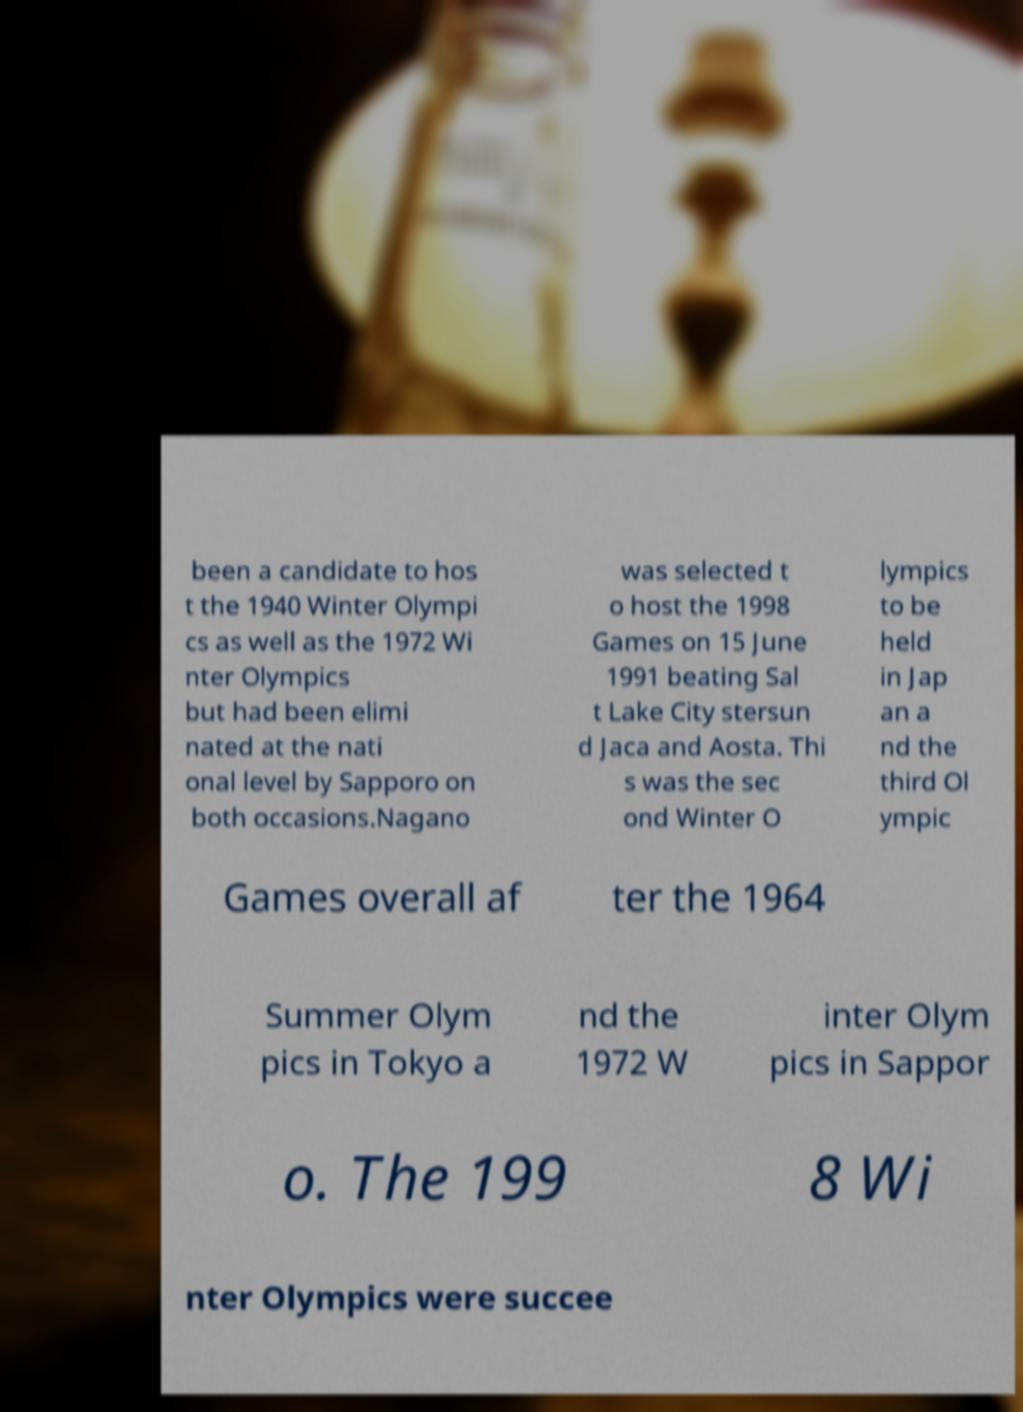Please read and relay the text visible in this image. What does it say? been a candidate to hos t the 1940 Winter Olympi cs as well as the 1972 Wi nter Olympics but had been elimi nated at the nati onal level by Sapporo on both occasions.Nagano was selected t o host the 1998 Games on 15 June 1991 beating Sal t Lake City stersun d Jaca and Aosta. Thi s was the sec ond Winter O lympics to be held in Jap an a nd the third Ol ympic Games overall af ter the 1964 Summer Olym pics in Tokyo a nd the 1972 W inter Olym pics in Sappor o. The 199 8 Wi nter Olympics were succee 